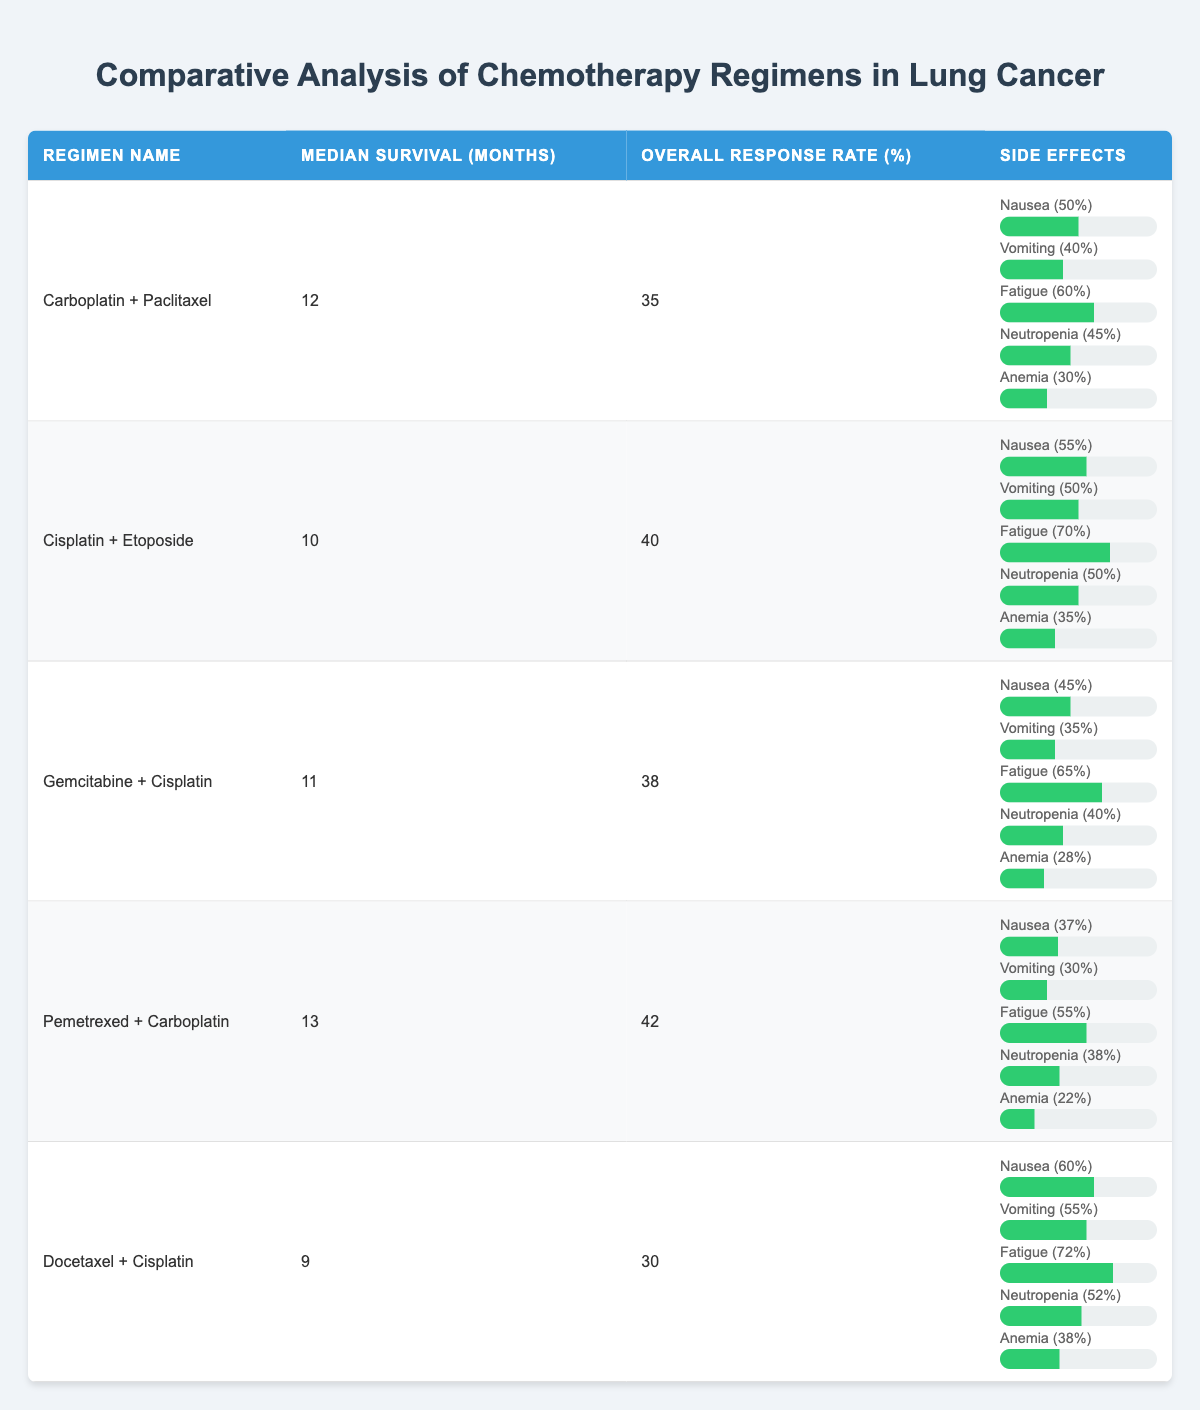What is the median survival time of the Pemetrexed + Carboplatin regimen? The median survival time for the Pemetrexed + Carboplatin regimen is provided directly in the table under the "Median Survival (months)" column for that regimen. It is 13 months.
Answer: 13 months Which chemotherapy regimen has the highest overall response rate? By examining the "Overall Response Rate (%)" column, the regimen with the highest percentage is Pemetrexed + Carboplatin with 42%.
Answer: Pemetrexed + Carboplatin What is the average overall response rate of the chemotherapy regimens listed? First, sum the overall response rates: 35 + 40 + 38 + 42 + 30 = 185. There are 5 regimens, so the average is 185/5 = 37.
Answer: 37 Is the nausea rate the same for Carboplatin + Paclitaxel and Gemcitabine + Cisplatin regimens? From the table, Carboplatin + Paclitaxel has a nausea rate of 50%, whereas Gemcitabine + Cisplatin has a rate of 45%. Therefore, they are not the same.
Answer: No Which regimen has the least percentage of fatigue as a side effect? Comparing the fatigue percentages under the side effects section: Carboplatin + Paclitaxel (60%), Cisplatin + Etoposide (70%), Gemcitabine + Cisplatin (65%), Pemetrexed + Carboplatin (55%), and Docetaxel + Cisplatin (72%). The least is seen in Pemetrexed + Carboplatin at 55%.
Answer: Pemetrexed + Carboplatin Are there any regimens with an anemia rate below 30%? The table lists the anemia rates: Carboplatin + Paclitaxel (30%), Cisplatin + Etoposide (35%), Gemcitabine + Cisplatin (28%), Pemetrexed + Carboplatin (22%), and Docetaxel + Cisplatin (38%). The only regimen with an anemia rate below 30% is Gemcitabine + Cisplatin (28%) and Pemetrexed + Carboplatin (22%). Therefore, yes, there are regimens with an anemia rate below 30%.
Answer: Yes What is the difference in median survival months between Docetaxel + Cisplatin and Pemetrexed + Carboplatin? The median survival for Docetaxel + Cisplatin is 9 months and for Pemetrexed + Carboplatin is 13 months. The difference is 13 - 9 = 4 months.
Answer: 4 months What is the combined nausea rate between Cisplatin + Etoposide and Docetaxel + Cisplatin? Add the nausea rates: Cisplatin + Etoposide has 55% and Docetaxel + Cisplatin has 60%. So, the combined rate is 55 + 60 = 115%.
Answer: 115% Which regimen has both the lowest median survival and the lowest response rate? Looking for the regimen with the lowest values in both "Median Survival (months)" and "Overall Response Rate (%)", Docetaxel + Cisplatin has 9 months and 30%, making it the lowest in both categories.
Answer: Docetaxel + Cisplatin 